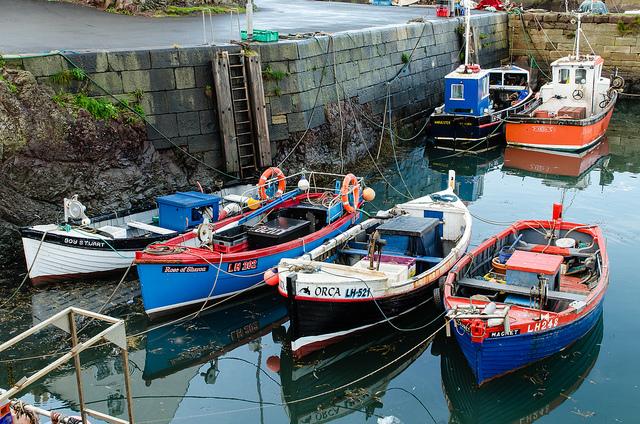How many boats are there?
Quick response, please. 6. Is the water still?
Answer briefly. Yes. Are these boats used for recreation fishing or business fishing?
Be succinct. Business. 